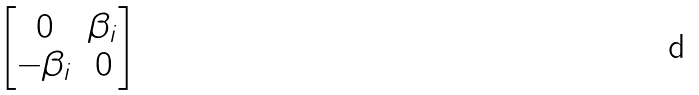<formula> <loc_0><loc_0><loc_500><loc_500>\begin{bmatrix} 0 & \beta _ { i } \\ - \beta _ { i } & 0 \end{bmatrix}</formula> 